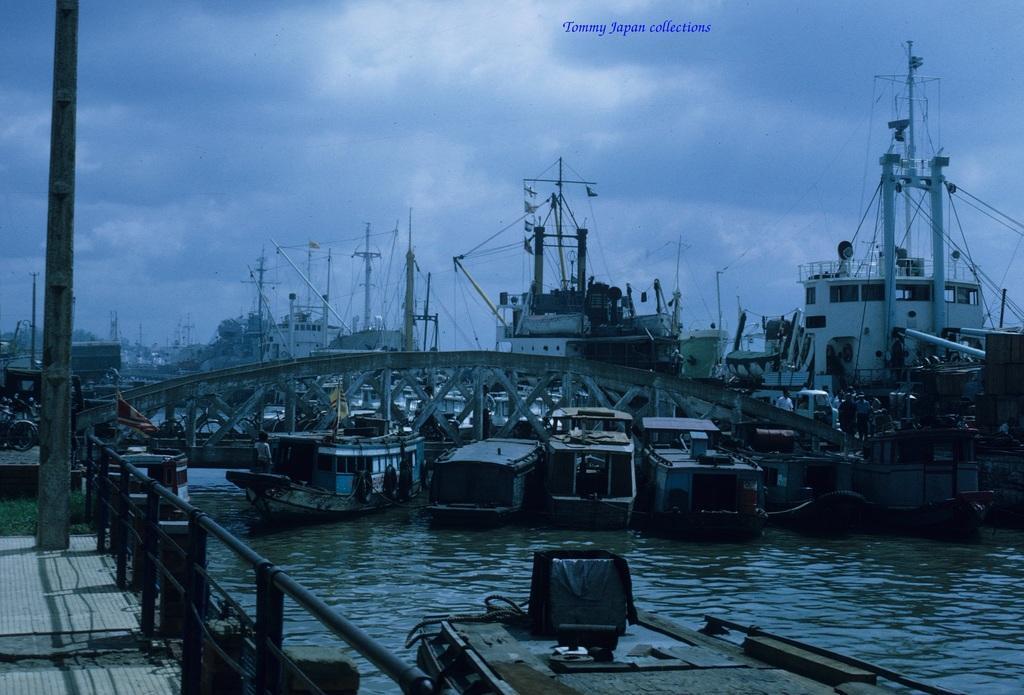How would you summarize this image in a sentence or two? In this image we can see boats on the water. Also there are ships. And there is a bridge with railings. On the left side there is a railing. Also there are poles. And we can see few people. In the background there is sky with clouds. Also there is watermark at the top. 